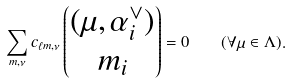<formula> <loc_0><loc_0><loc_500><loc_500>\sum _ { m , \nu } c _ { \ell m , \nu } \begin{pmatrix} { ( \mu , \alpha _ { i } ^ { \vee } ) } \\ { m _ { i } } \end{pmatrix} = 0 \quad ( \forall \mu \in \Lambda ) .</formula> 